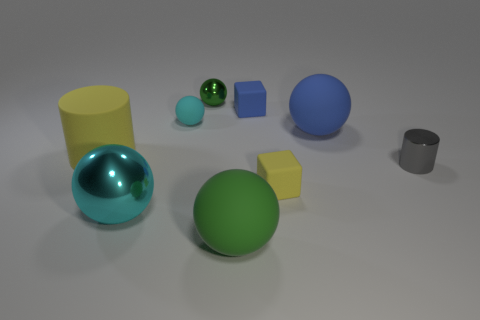How many tiny cyan spheres are made of the same material as the small yellow object?
Ensure brevity in your answer.  1. Are there any green objects behind the cyan metal sphere in front of the cyan object behind the large cylinder?
Offer a terse response. Yes. How many blocks are gray objects or small yellow rubber things?
Make the answer very short. 1. There is a large cyan shiny thing; is its shape the same as the big matte object on the left side of the tiny green metal thing?
Offer a very short reply. No. Is the number of tiny yellow rubber things that are on the left side of the tiny green metallic thing less than the number of red matte cylinders?
Offer a very short reply. No. There is a tiny yellow block; are there any green spheres on the left side of it?
Make the answer very short. Yes. Is there a tiny red thing of the same shape as the large shiny object?
Give a very brief answer. No. The cyan metal thing that is the same size as the green rubber sphere is what shape?
Make the answer very short. Sphere. What number of objects are either metal things that are to the left of the blue rubber sphere or rubber objects?
Your answer should be compact. 8. Is the color of the big shiny object the same as the small rubber ball?
Your answer should be compact. Yes. 